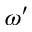<formula> <loc_0><loc_0><loc_500><loc_500>\omega ^ { \prime }</formula> 